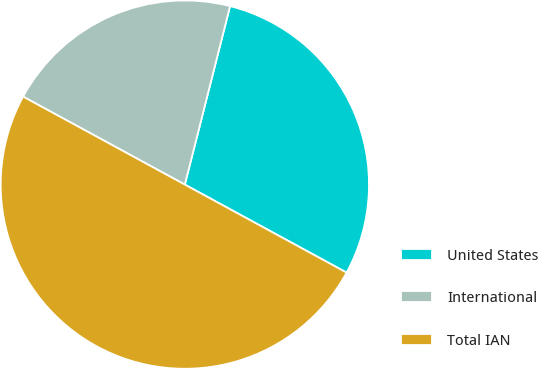<chart> <loc_0><loc_0><loc_500><loc_500><pie_chart><fcel>United States<fcel>International<fcel>Total IAN<nl><fcel>28.98%<fcel>21.02%<fcel>50.0%<nl></chart> 